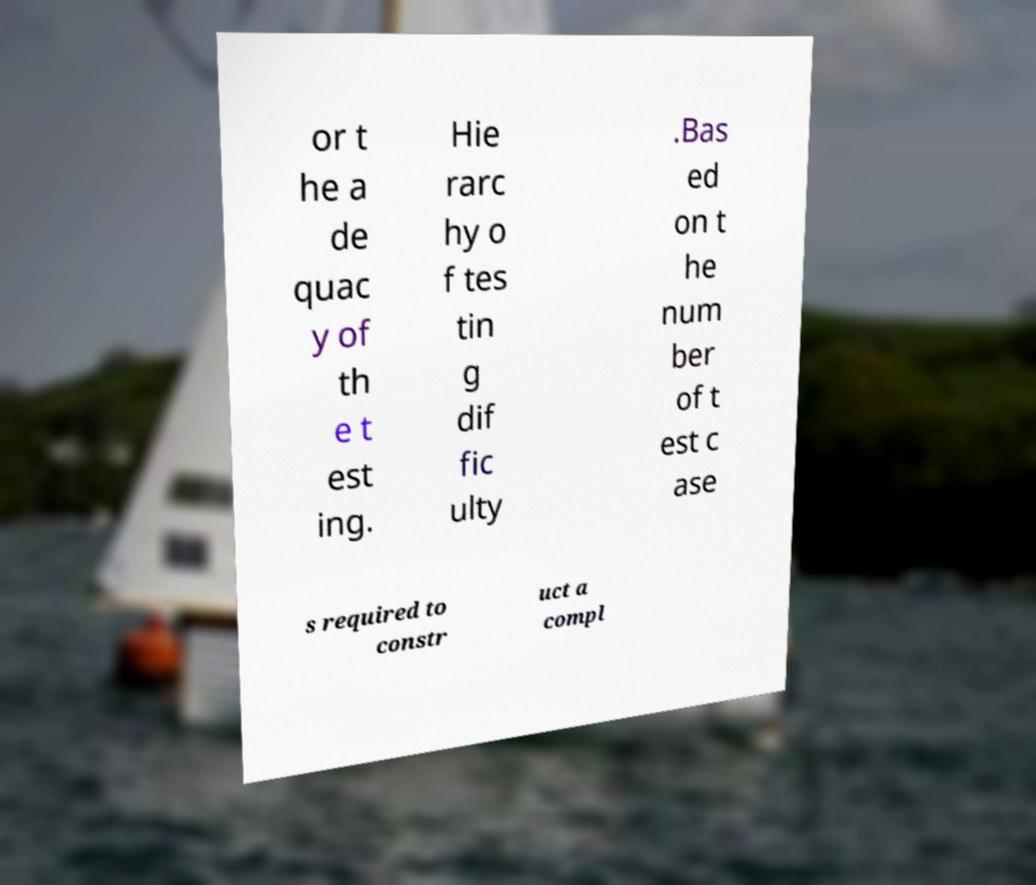For documentation purposes, I need the text within this image transcribed. Could you provide that? or t he a de quac y of th e t est ing. Hie rarc hy o f tes tin g dif fic ulty .Bas ed on t he num ber of t est c ase s required to constr uct a compl 